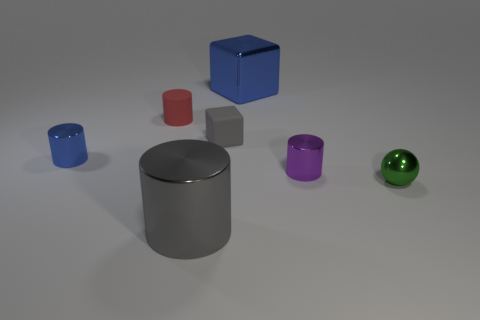Is the color of the tiny metal object to the left of the big metallic cube the same as the big object that is behind the green thing?
Provide a short and direct response. Yes. There is a blue thing that is the same size as the gray metallic object; what shape is it?
Your response must be concise. Cube. Is the number of small red rubber cylinders greater than the number of brown balls?
Your answer should be very brief. Yes. There is a tiny thing that is on the right side of the purple cylinder; are there any rubber cubes behind it?
Your response must be concise. Yes. What is the color of the other object that is the same shape as the large blue shiny thing?
Ensure brevity in your answer.  Gray. Is there anything else that is the same shape as the green shiny object?
Provide a short and direct response. No. What color is the sphere that is the same material as the big blue thing?
Offer a terse response. Green. There is a big metallic thing that is behind the blue metal thing that is to the left of the small matte cylinder; is there a tiny metal cylinder that is to the left of it?
Provide a succinct answer. Yes. Is the number of blue shiny cubes left of the large blue metallic block less than the number of tiny metal cylinders that are behind the small purple shiny thing?
Offer a very short reply. Yes. What number of big blue cubes are made of the same material as the small blue object?
Your answer should be compact. 1. 